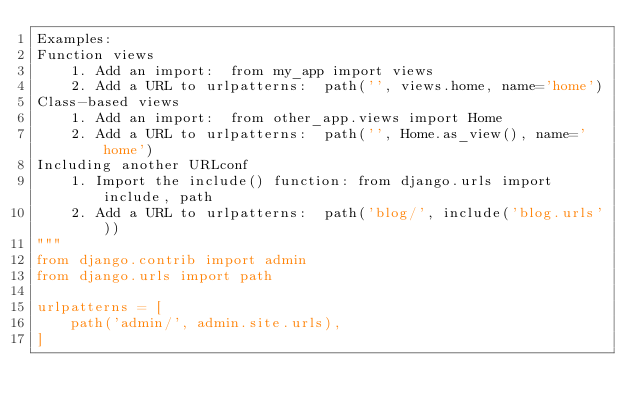Convert code to text. <code><loc_0><loc_0><loc_500><loc_500><_Python_>Examples:
Function views
    1. Add an import:  from my_app import views
    2. Add a URL to urlpatterns:  path('', views.home, name='home')
Class-based views
    1. Add an import:  from other_app.views import Home
    2. Add a URL to urlpatterns:  path('', Home.as_view(), name='home')
Including another URLconf
    1. Import the include() function: from django.urls import include, path
    2. Add a URL to urlpatterns:  path('blog/', include('blog.urls'))
"""
from django.contrib import admin
from django.urls import path

urlpatterns = [
    path('admin/', admin.site.urls),
]
</code> 